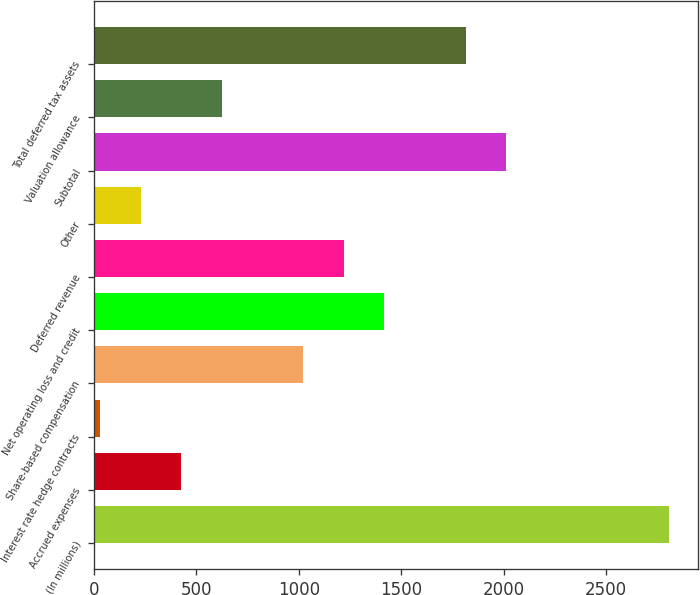<chart> <loc_0><loc_0><loc_500><loc_500><bar_chart><fcel>(In millions)<fcel>Accrued expenses<fcel>Interest rate hedge contracts<fcel>Share-based compensation<fcel>Net operating loss and credit<fcel>Deferred revenue<fcel>Other<fcel>Subtotal<fcel>Valuation allowance<fcel>Total deferred tax assets<nl><fcel>2808.4<fcel>425.2<fcel>28<fcel>1021<fcel>1418.2<fcel>1219.6<fcel>226.6<fcel>2014<fcel>623.8<fcel>1815.4<nl></chart> 